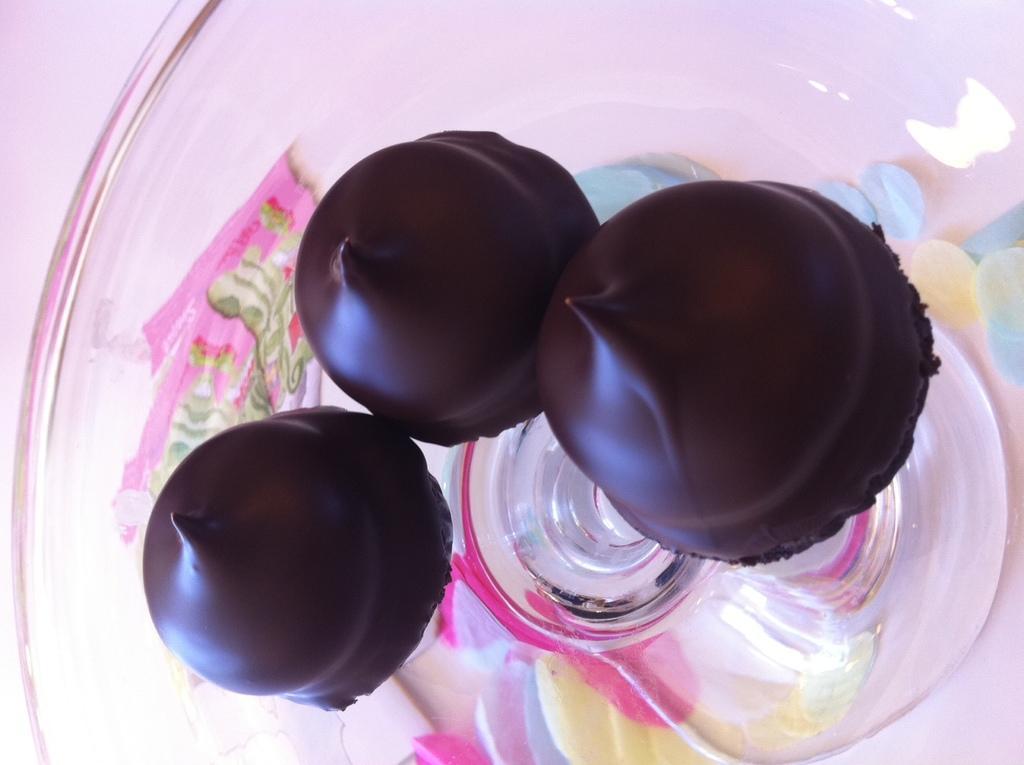How would you summarize this image in a sentence or two? In this image we can see chocolates placed on the table. 